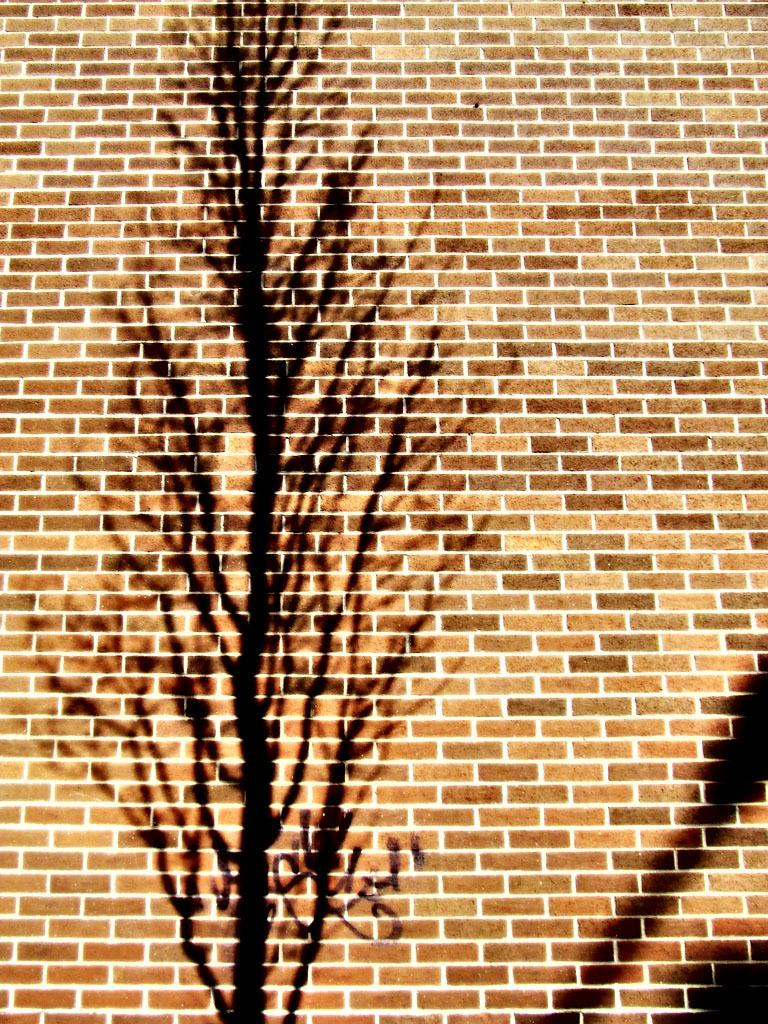Where was the image taken? The image was taken outdoors. What can be seen in the image besides the outdoor setting? There is a wall in the image. What is the source of the shadow on the wall? The shadow on the wall is from a tree. How many eggs are visible on the wall in the image? There are no eggs visible on the wall in the image. What type of knowledge is being shared in the image? The image does not depict any knowledge being shared; it primarily features a wall with a shadow of a tree. 